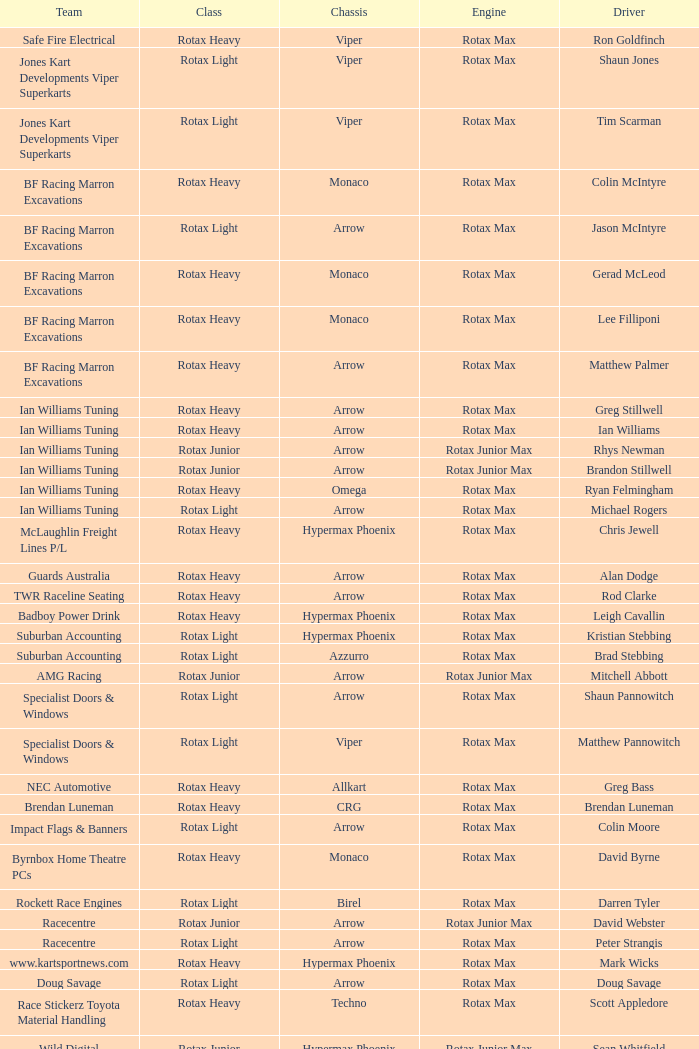Which team does Colin Moore drive for? Impact Flags & Banners. 